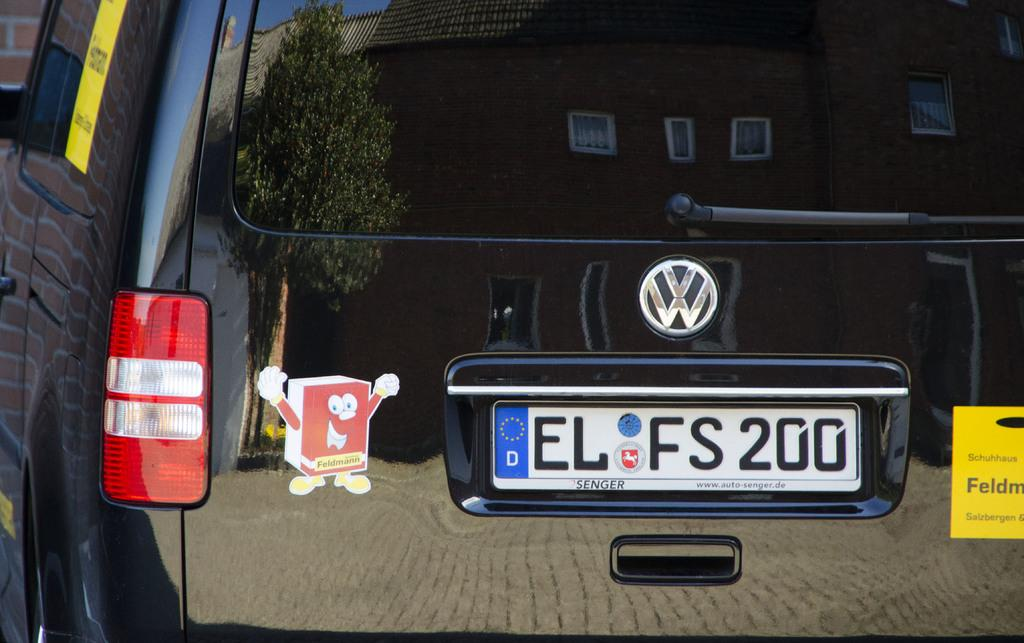<image>
Render a clear and concise summary of the photo. A black vehicle in Europe has a license plate number EL FS200. 